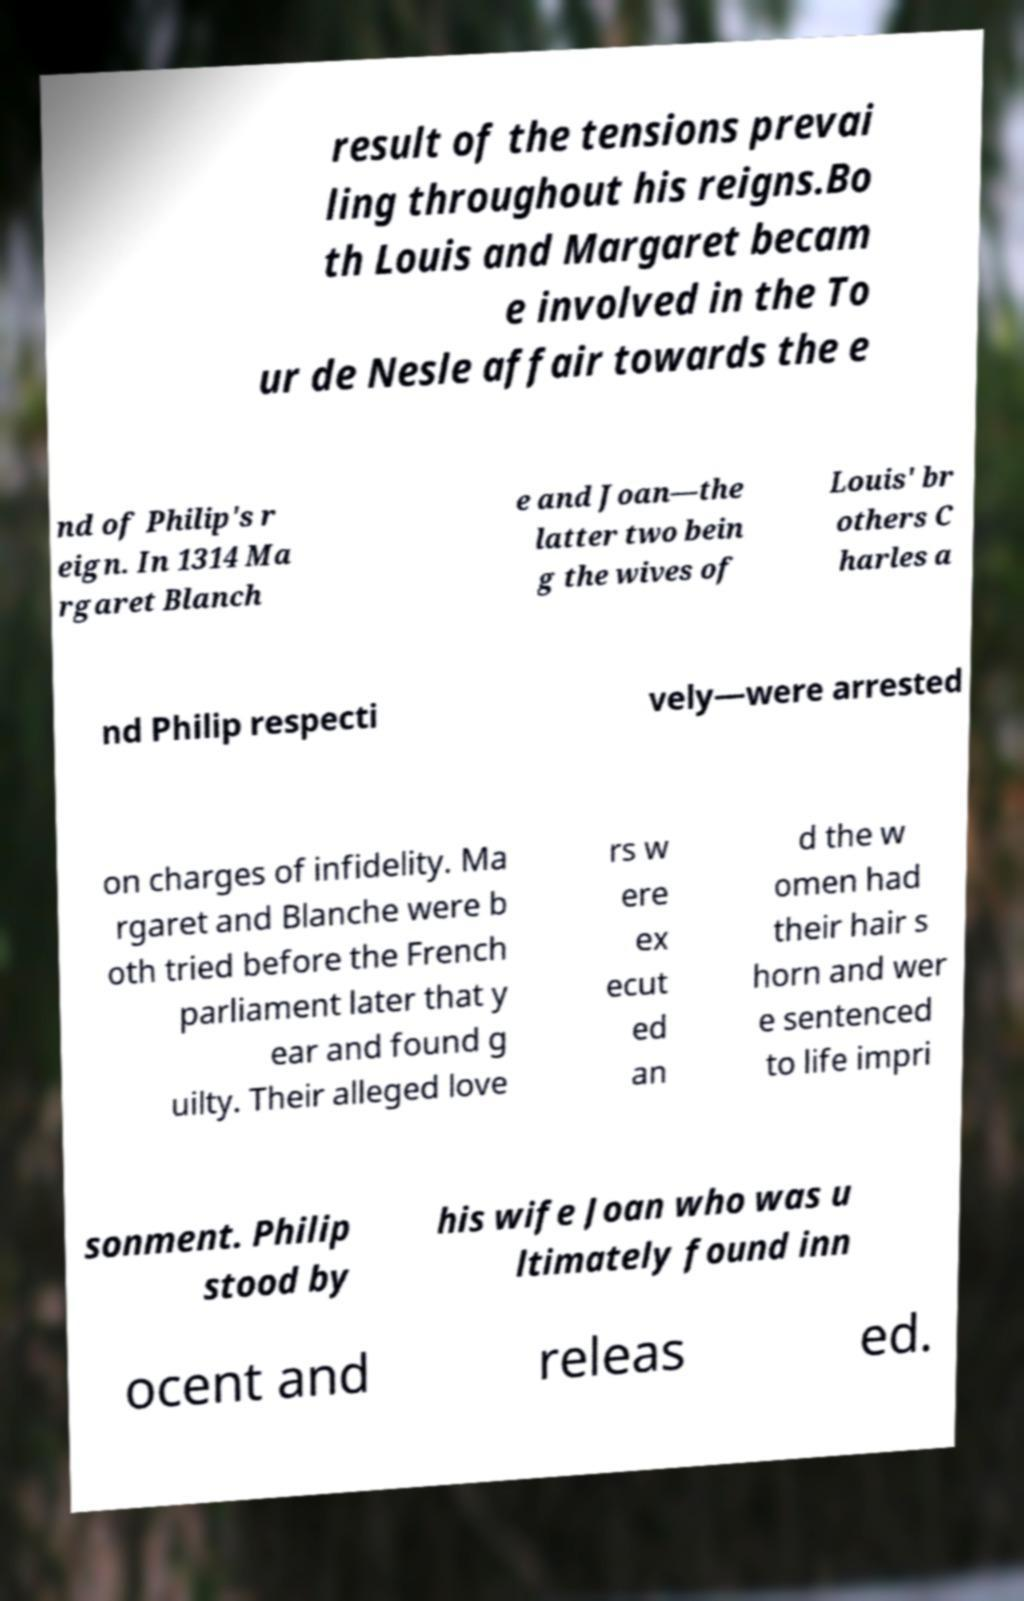Can you read and provide the text displayed in the image?This photo seems to have some interesting text. Can you extract and type it out for me? result of the tensions prevai ling throughout his reigns.Bo th Louis and Margaret becam e involved in the To ur de Nesle affair towards the e nd of Philip's r eign. In 1314 Ma rgaret Blanch e and Joan—the latter two bein g the wives of Louis' br others C harles a nd Philip respecti vely—were arrested on charges of infidelity. Ma rgaret and Blanche were b oth tried before the French parliament later that y ear and found g uilty. Their alleged love rs w ere ex ecut ed an d the w omen had their hair s horn and wer e sentenced to life impri sonment. Philip stood by his wife Joan who was u ltimately found inn ocent and releas ed. 